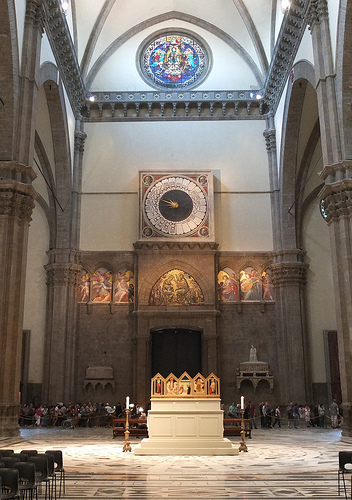Imagine a historical event that could have taken place in this location. Describe it in detail. In the year 1452, the grand cathedral witnessed a monumental coronation of a new bishop. Dignitaries and nobility from far and wide gathered in the sacred space, the sunlight streaming in through the stained glass windows casting a rainbow of colors on the polished marble floor. The air was thick with the scent of incense, and the choir's voices echoed through the arches, singing hymns that elevated the spirits of all those present. The bishop, clad in elaborate robes adorned with gold and jewels, slowly ascended the steps to the altar. With a solemn vow, he took his place, guiding the spiritual journey of his people. The entire event was a display of grandeur, faith, and unity, marking a significant chapter in the cathedral's long and storied history. 